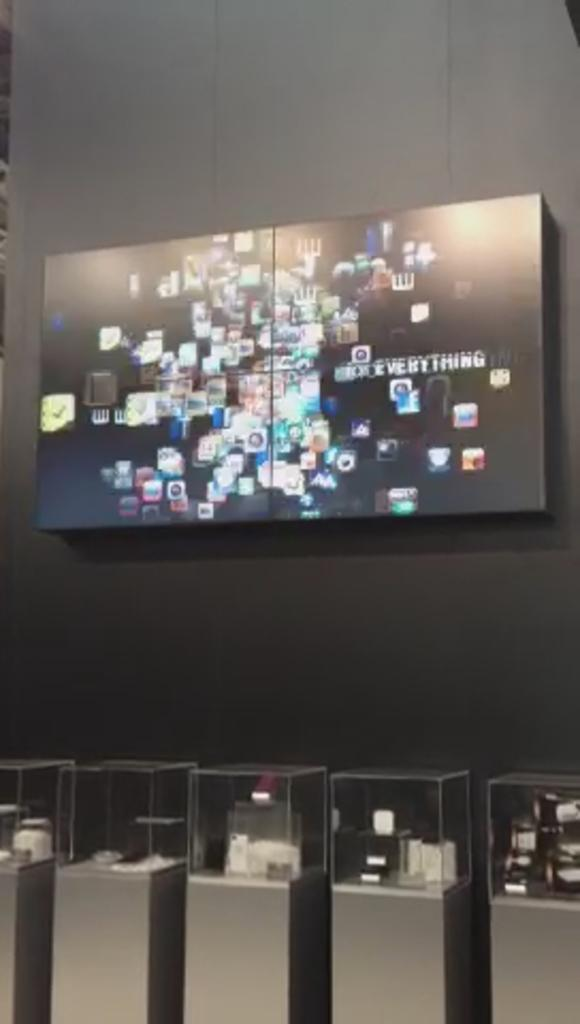<image>
Describe the image concisely. the name everything is on the television screen 